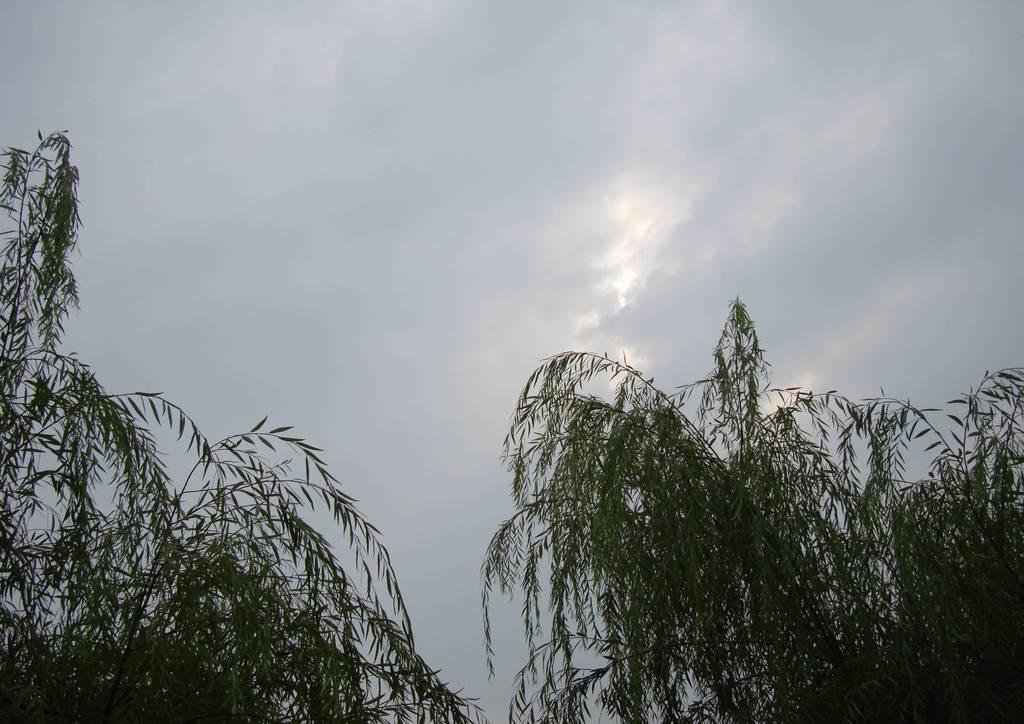How would you summarize this image in a sentence or two? In this picture there are some trees in the front. Behind we can see the cloudy sky. 